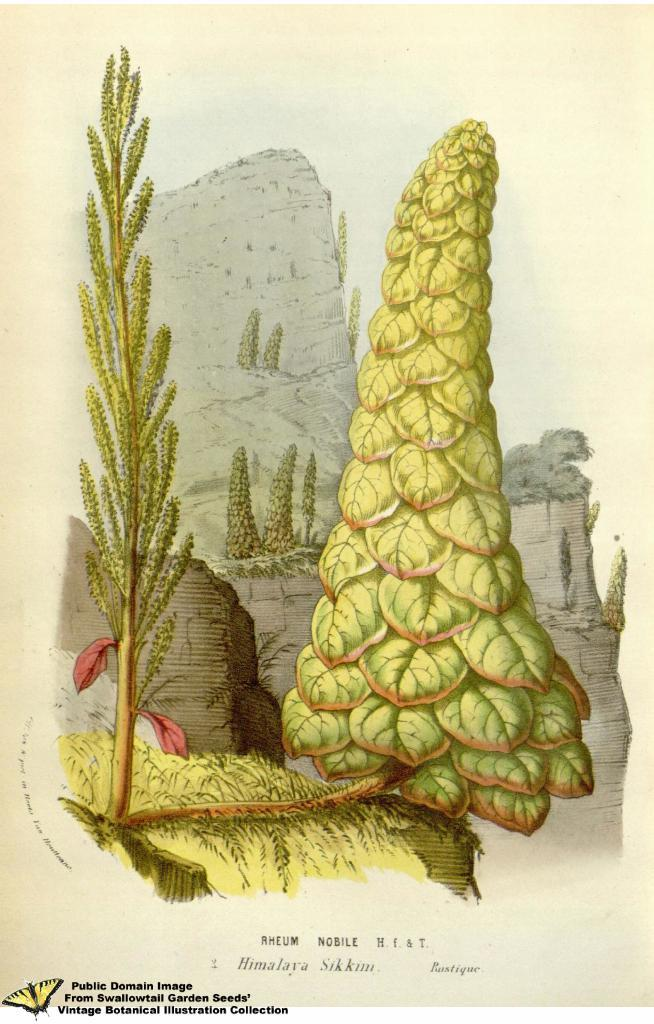What type of image is being described? The image is an animated image. What natural elements can be seen in the image? There are plants, rocks, and trees in the image. What type of celery is being sold in the shop in the image? There is no shop or celery present in the image; it features animated plants, rocks, and trees. 